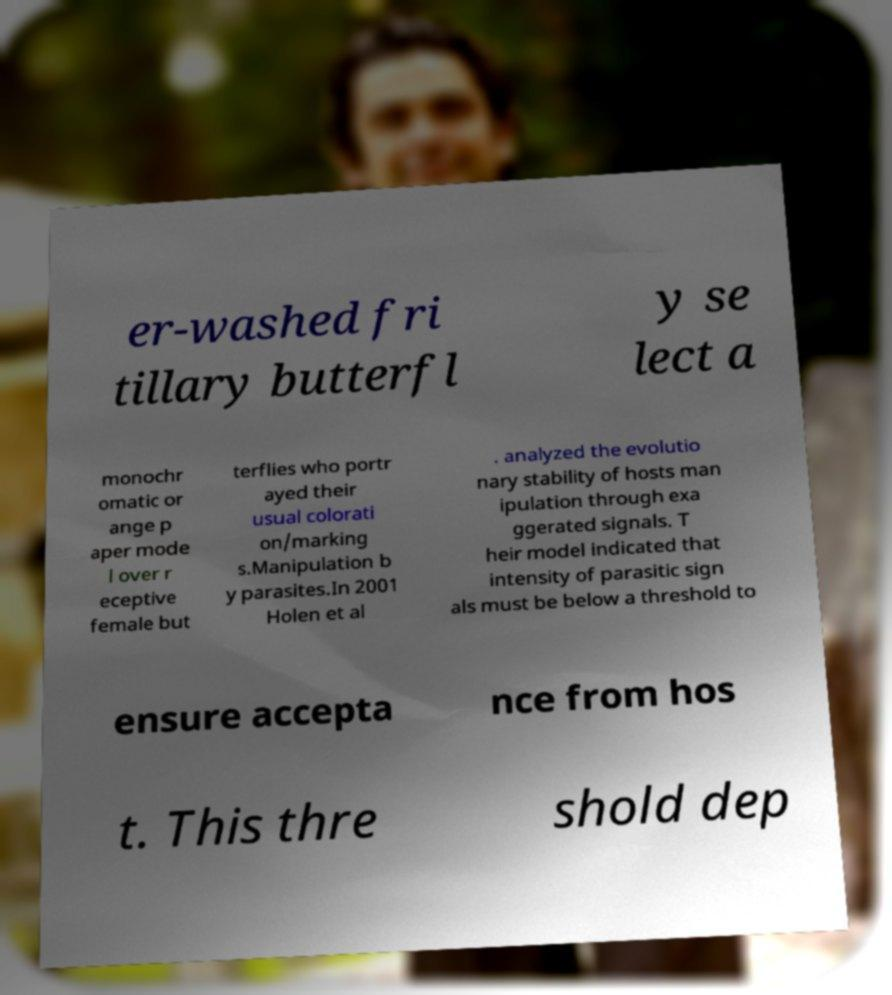There's text embedded in this image that I need extracted. Can you transcribe it verbatim? er-washed fri tillary butterfl y se lect a monochr omatic or ange p aper mode l over r eceptive female but terflies who portr ayed their usual colorati on/marking s.Manipulation b y parasites.In 2001 Holen et al . analyzed the evolutio nary stability of hosts man ipulation through exa ggerated signals. T heir model indicated that intensity of parasitic sign als must be below a threshold to ensure accepta nce from hos t. This thre shold dep 